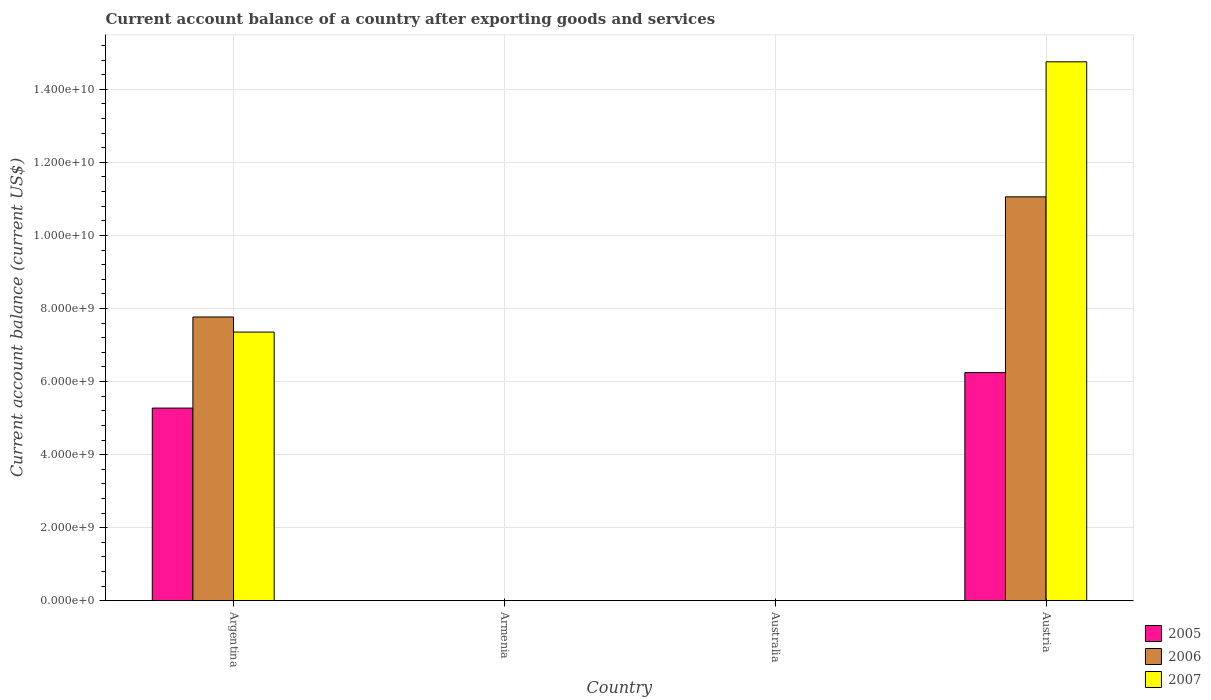How many different coloured bars are there?
Ensure brevity in your answer.  3. Are the number of bars per tick equal to the number of legend labels?
Make the answer very short. No. Are the number of bars on each tick of the X-axis equal?
Offer a very short reply. No. How many bars are there on the 4th tick from the left?
Give a very brief answer. 3. How many bars are there on the 3rd tick from the right?
Provide a short and direct response. 0. What is the label of the 1st group of bars from the left?
Give a very brief answer. Argentina. In how many cases, is the number of bars for a given country not equal to the number of legend labels?
Give a very brief answer. 2. What is the account balance in 2006 in Argentina?
Your response must be concise. 7.77e+09. Across all countries, what is the maximum account balance in 2007?
Your response must be concise. 1.48e+1. In which country was the account balance in 2007 maximum?
Offer a very short reply. Austria. What is the total account balance in 2006 in the graph?
Your answer should be very brief. 1.88e+1. What is the difference between the account balance in 2006 in Argentina and that in Austria?
Make the answer very short. -3.29e+09. What is the difference between the account balance in 2005 in Armenia and the account balance in 2006 in Australia?
Keep it short and to the point. 0. What is the average account balance in 2005 per country?
Make the answer very short. 2.88e+09. What is the difference between the account balance of/in 2007 and account balance of/in 2005 in Argentina?
Ensure brevity in your answer.  2.08e+09. Is the difference between the account balance in 2007 in Argentina and Austria greater than the difference between the account balance in 2005 in Argentina and Austria?
Give a very brief answer. No. What is the difference between the highest and the lowest account balance in 2007?
Ensure brevity in your answer.  1.48e+1. In how many countries, is the account balance in 2006 greater than the average account balance in 2006 taken over all countries?
Your answer should be very brief. 2. How many bars are there?
Your answer should be very brief. 6. Are all the bars in the graph horizontal?
Make the answer very short. No. How many countries are there in the graph?
Make the answer very short. 4. What is the difference between two consecutive major ticks on the Y-axis?
Offer a very short reply. 2.00e+09. Does the graph contain grids?
Offer a very short reply. Yes. How many legend labels are there?
Keep it short and to the point. 3. How are the legend labels stacked?
Offer a very short reply. Vertical. What is the title of the graph?
Ensure brevity in your answer.  Current account balance of a country after exporting goods and services. Does "1981" appear as one of the legend labels in the graph?
Offer a very short reply. No. What is the label or title of the Y-axis?
Keep it short and to the point. Current account balance (current US$). What is the Current account balance (current US$) in 2005 in Argentina?
Give a very brief answer. 5.27e+09. What is the Current account balance (current US$) of 2006 in Argentina?
Your response must be concise. 7.77e+09. What is the Current account balance (current US$) of 2007 in Argentina?
Offer a terse response. 7.35e+09. What is the Current account balance (current US$) in 2007 in Armenia?
Your answer should be compact. 0. What is the Current account balance (current US$) of 2005 in Australia?
Offer a terse response. 0. What is the Current account balance (current US$) of 2006 in Australia?
Offer a terse response. 0. What is the Current account balance (current US$) in 2007 in Australia?
Make the answer very short. 0. What is the Current account balance (current US$) in 2005 in Austria?
Your answer should be very brief. 6.25e+09. What is the Current account balance (current US$) of 2006 in Austria?
Your answer should be very brief. 1.11e+1. What is the Current account balance (current US$) of 2007 in Austria?
Your answer should be compact. 1.48e+1. Across all countries, what is the maximum Current account balance (current US$) of 2005?
Your response must be concise. 6.25e+09. Across all countries, what is the maximum Current account balance (current US$) in 2006?
Provide a short and direct response. 1.11e+1. Across all countries, what is the maximum Current account balance (current US$) of 2007?
Your answer should be very brief. 1.48e+1. What is the total Current account balance (current US$) in 2005 in the graph?
Provide a succinct answer. 1.15e+1. What is the total Current account balance (current US$) in 2006 in the graph?
Provide a short and direct response. 1.88e+1. What is the total Current account balance (current US$) in 2007 in the graph?
Your answer should be very brief. 2.21e+1. What is the difference between the Current account balance (current US$) in 2005 in Argentina and that in Austria?
Provide a short and direct response. -9.71e+08. What is the difference between the Current account balance (current US$) in 2006 in Argentina and that in Austria?
Your response must be concise. -3.29e+09. What is the difference between the Current account balance (current US$) in 2007 in Argentina and that in Austria?
Your response must be concise. -7.40e+09. What is the difference between the Current account balance (current US$) of 2005 in Argentina and the Current account balance (current US$) of 2006 in Austria?
Ensure brevity in your answer.  -5.78e+09. What is the difference between the Current account balance (current US$) of 2005 in Argentina and the Current account balance (current US$) of 2007 in Austria?
Your response must be concise. -9.48e+09. What is the difference between the Current account balance (current US$) of 2006 in Argentina and the Current account balance (current US$) of 2007 in Austria?
Your answer should be very brief. -6.98e+09. What is the average Current account balance (current US$) in 2005 per country?
Give a very brief answer. 2.88e+09. What is the average Current account balance (current US$) of 2006 per country?
Provide a short and direct response. 4.71e+09. What is the average Current account balance (current US$) in 2007 per country?
Provide a succinct answer. 5.53e+09. What is the difference between the Current account balance (current US$) in 2005 and Current account balance (current US$) in 2006 in Argentina?
Provide a succinct answer. -2.49e+09. What is the difference between the Current account balance (current US$) of 2005 and Current account balance (current US$) of 2007 in Argentina?
Offer a terse response. -2.08e+09. What is the difference between the Current account balance (current US$) of 2006 and Current account balance (current US$) of 2007 in Argentina?
Your answer should be compact. 4.13e+08. What is the difference between the Current account balance (current US$) in 2005 and Current account balance (current US$) in 2006 in Austria?
Provide a succinct answer. -4.81e+09. What is the difference between the Current account balance (current US$) of 2005 and Current account balance (current US$) of 2007 in Austria?
Keep it short and to the point. -8.51e+09. What is the difference between the Current account balance (current US$) in 2006 and Current account balance (current US$) in 2007 in Austria?
Your answer should be compact. -3.70e+09. What is the ratio of the Current account balance (current US$) in 2005 in Argentina to that in Austria?
Ensure brevity in your answer.  0.84. What is the ratio of the Current account balance (current US$) of 2006 in Argentina to that in Austria?
Make the answer very short. 0.7. What is the ratio of the Current account balance (current US$) of 2007 in Argentina to that in Austria?
Your response must be concise. 0.5. What is the difference between the highest and the lowest Current account balance (current US$) of 2005?
Keep it short and to the point. 6.25e+09. What is the difference between the highest and the lowest Current account balance (current US$) of 2006?
Your answer should be very brief. 1.11e+1. What is the difference between the highest and the lowest Current account balance (current US$) in 2007?
Give a very brief answer. 1.48e+1. 